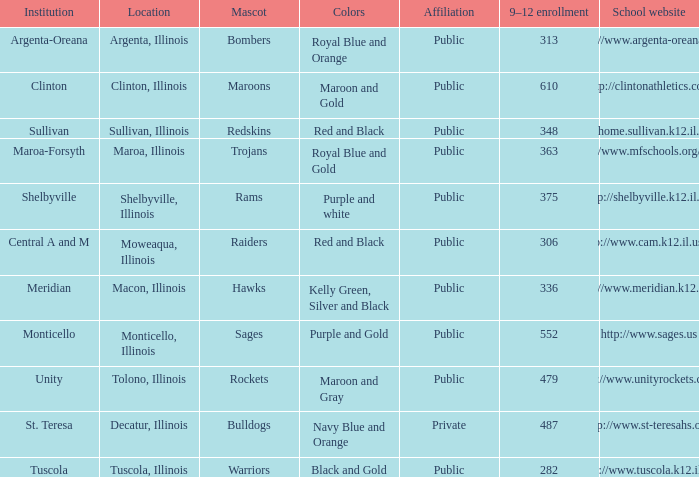How many different combinations of team colors are there in all the schools in Maroa, Illinois? 1.0. Would you be able to parse every entry in this table? {'header': ['Institution', 'Location', 'Mascot', 'Colors', 'Affiliation', '9–12 enrollment', 'School website'], 'rows': [['Argenta-Oreana', 'Argenta, Illinois', 'Bombers', 'Royal Blue and Orange', 'Public', '313', 'http://www.argenta-oreana.org'], ['Clinton', 'Clinton, Illinois', 'Maroons', 'Maroon and Gold', 'Public', '610', 'http://clintonathletics.com'], ['Sullivan', 'Sullivan, Illinois', 'Redskins', 'Red and Black', 'Public', '348', 'http://home.sullivan.k12.il.us/shs'], ['Maroa-Forsyth', 'Maroa, Illinois', 'Trojans', 'Royal Blue and Gold', 'Public', '363', 'http://www.mfschools.org/high/'], ['Shelbyville', 'Shelbyville, Illinois', 'Rams', 'Purple and white', 'Public', '375', 'http://shelbyville.k12.il.us/'], ['Central A and M', 'Moweaqua, Illinois', 'Raiders', 'Red and Black', 'Public', '306', 'http://www.cam.k12.il.us/hs'], ['Meridian', 'Macon, Illinois', 'Hawks', 'Kelly Green, Silver and Black', 'Public', '336', 'http://www.meridian.k12.il.us/'], ['Monticello', 'Monticello, Illinois', 'Sages', 'Purple and Gold', 'Public', '552', 'http://www.sages.us'], ['Unity', 'Tolono, Illinois', 'Rockets', 'Maroon and Gray', 'Public', '479', 'http://www.unityrockets.com/'], ['St. Teresa', 'Decatur, Illinois', 'Bulldogs', 'Navy Blue and Orange', 'Private', '487', 'http://www.st-teresahs.org/'], ['Tuscola', 'Tuscola, Illinois', 'Warriors', 'Black and Gold', 'Public', '282', 'http://www.tuscola.k12.il.us/']]} 